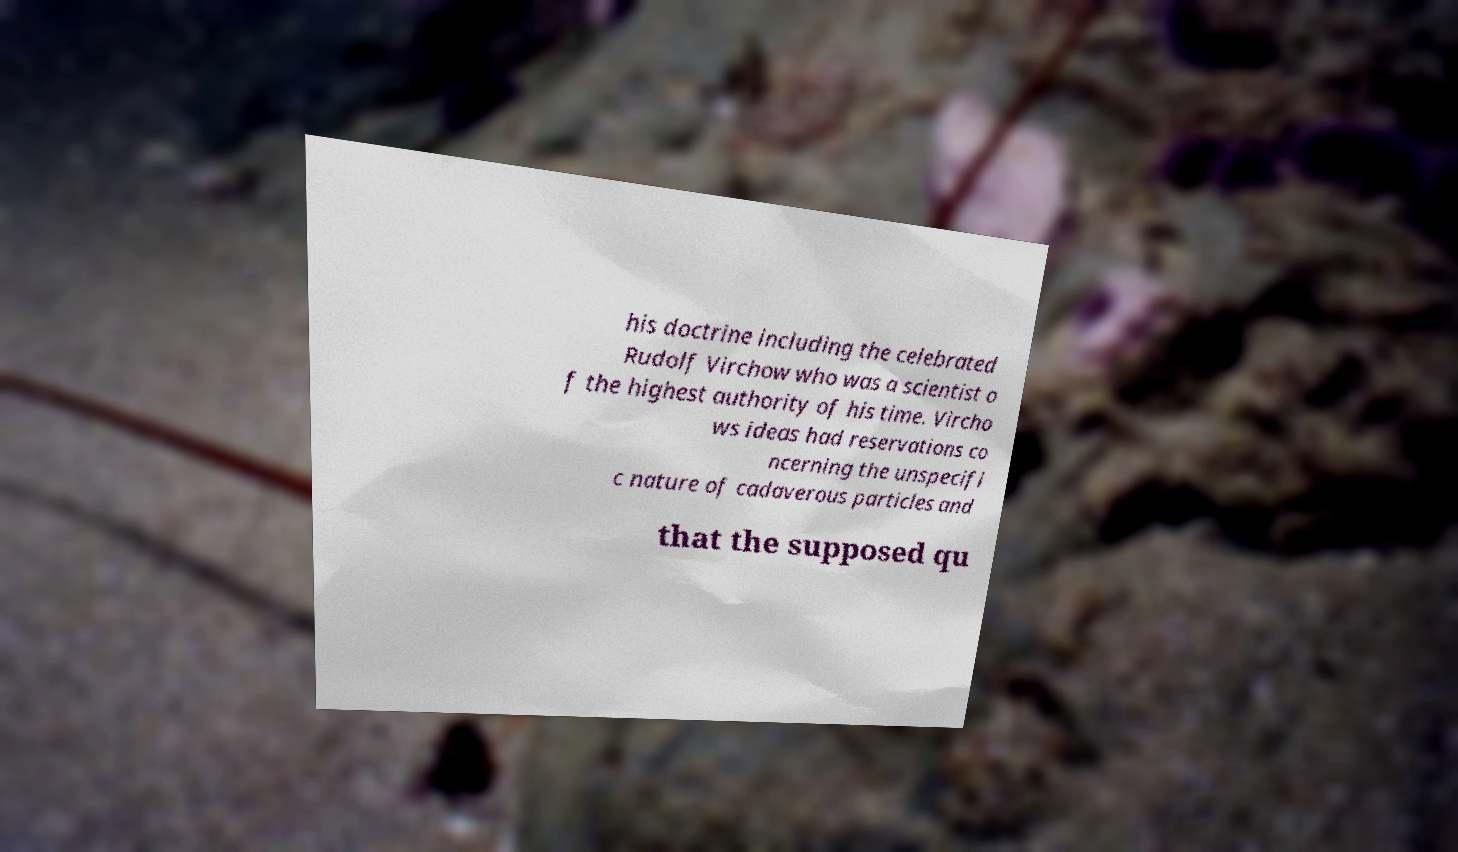Can you accurately transcribe the text from the provided image for me? his doctrine including the celebrated Rudolf Virchow who was a scientist o f the highest authority of his time. Vircho ws ideas had reservations co ncerning the unspecifi c nature of cadaverous particles and that the supposed qu 